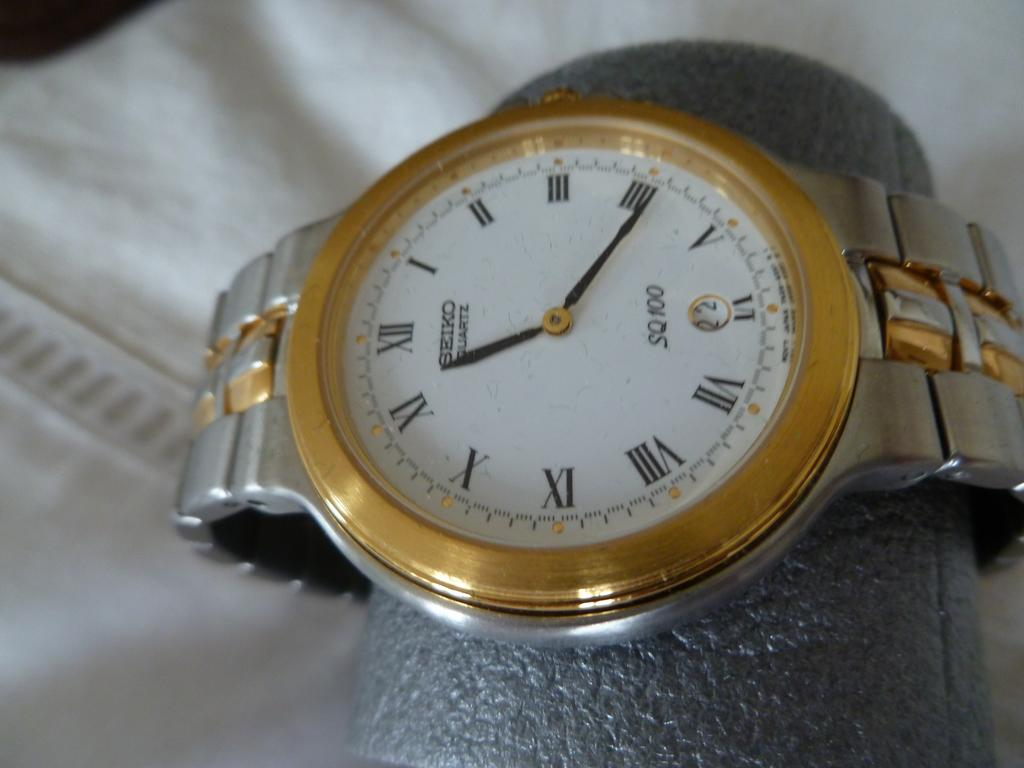<image>
Summarize the visual content of the image. A Seiko wristwatch is on a display against a white cloth. 